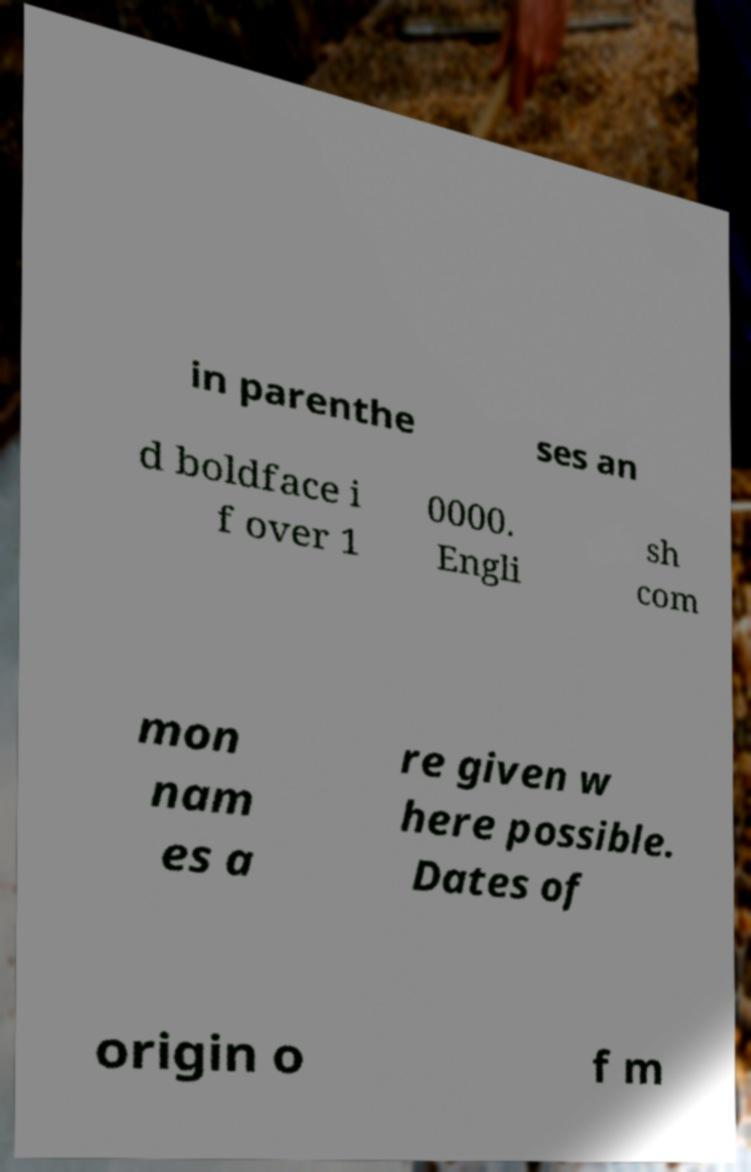Can you accurately transcribe the text from the provided image for me? in parenthe ses an d boldface i f over 1 0000. Engli sh com mon nam es a re given w here possible. Dates of origin o f m 